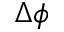<formula> <loc_0><loc_0><loc_500><loc_500>\Delta \phi</formula> 